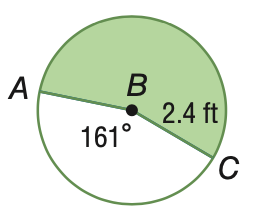Question: Find the area of the shaded sector. Round to the nearest tenth.
Choices:
A. 6.7
B. 8.1
C. 8.3
D. 10.0
Answer with the letter. Answer: D 